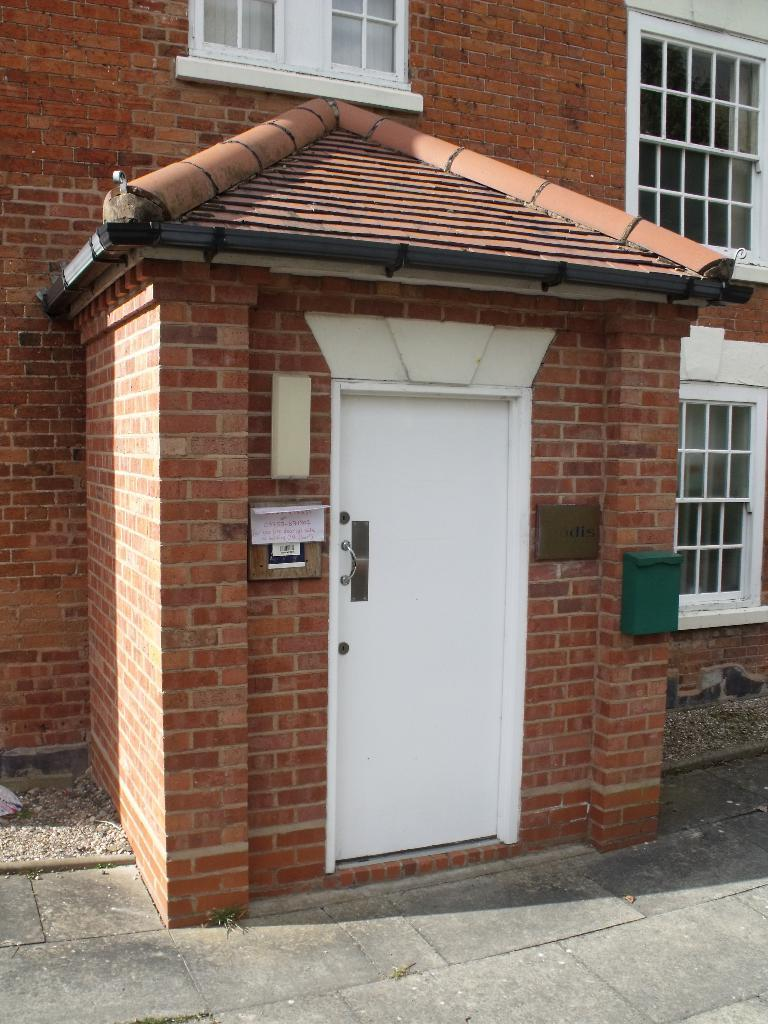What type of structure is visible in the image? There is a house in the image. What feature of the house is visible in the image? There is a door in the image. What color is the door? The door is white in color. What type of underwear is hanging on the door in the image? There is no underwear present in the image; the door is white in color. Is there a scarf draped over the door in the image? There is no scarf present in the image; the door is white in color. 